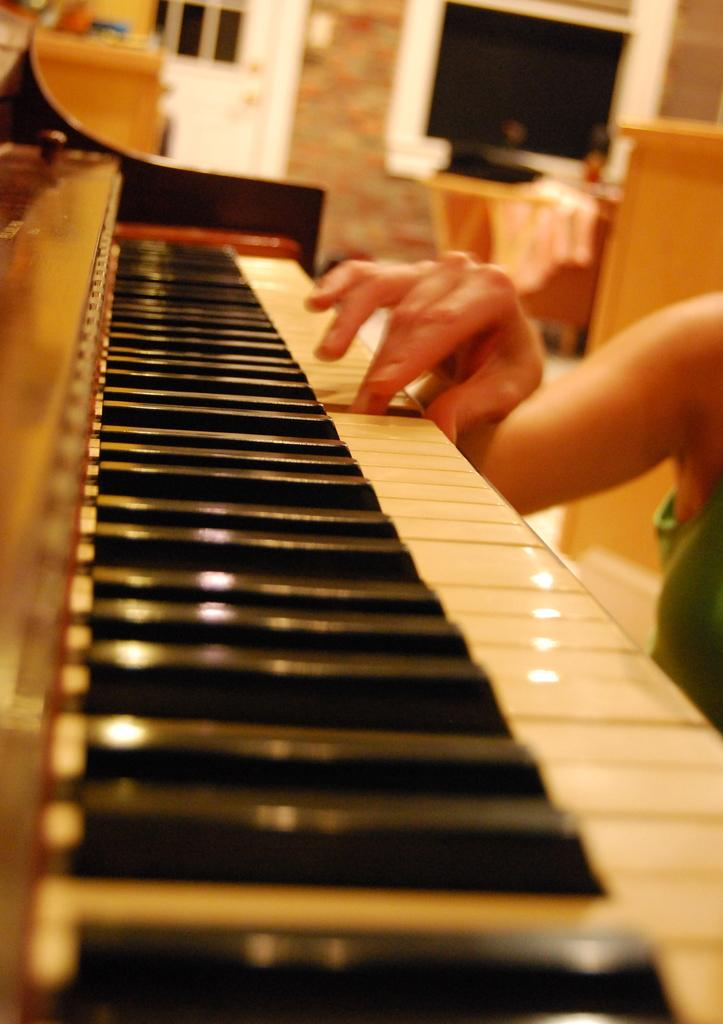Who is the person in the image? There is a woman in the image. What is the woman doing in the image? The woman is playing a piano. What other objects can be seen in the image? There is a television and a chair in the image. Is there any source of natural light in the image? Yes, there is a window in the image. What type of bike is the woman riding in the image? There is no bike present in the image; the woman is playing a piano. What is the woman writing on the piano in the image? The woman is not writing on the piano in the image; she is playing it. 